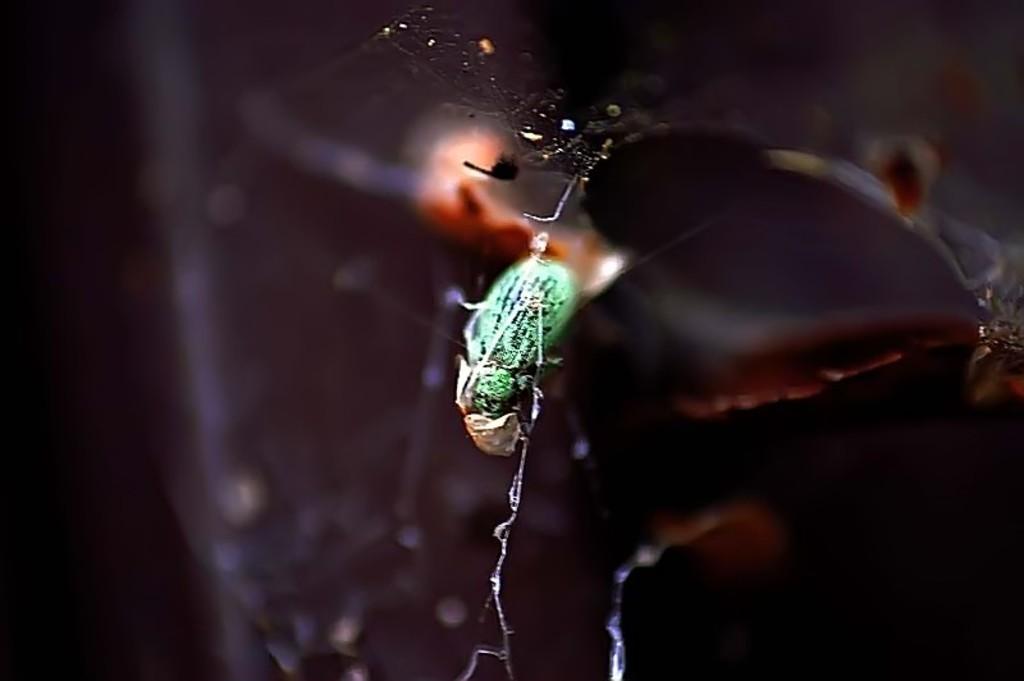Can you describe this image briefly? In this image, we can see an insect. Background there is a blur view. 